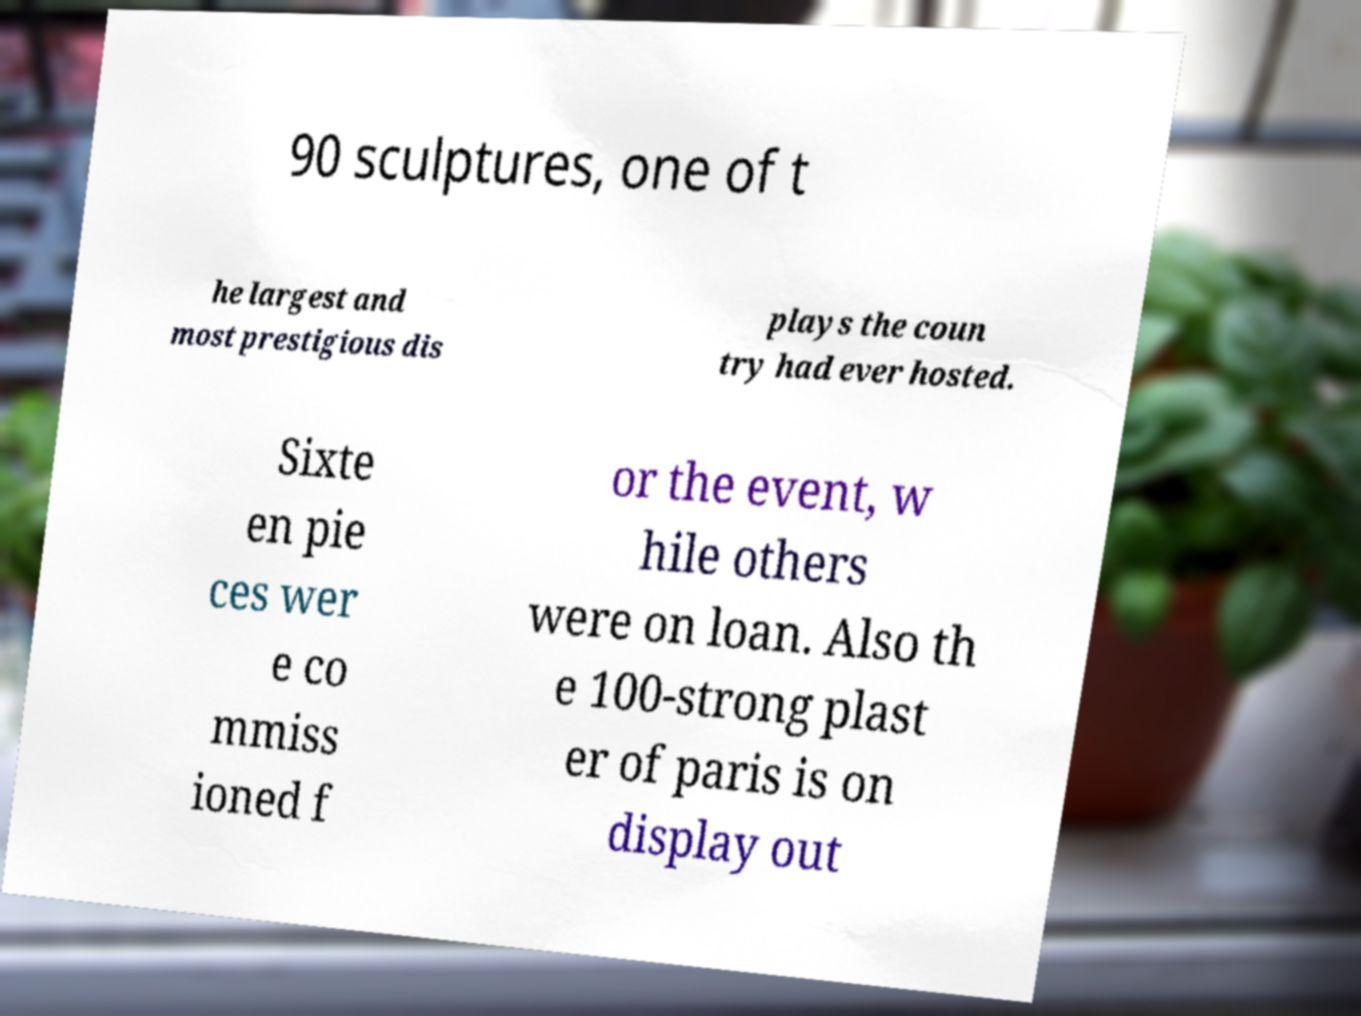Could you assist in decoding the text presented in this image and type it out clearly? 90 sculptures, one of t he largest and most prestigious dis plays the coun try had ever hosted. Sixte en pie ces wer e co mmiss ioned f or the event, w hile others were on loan. Also th e 100-strong plast er of paris is on display out 